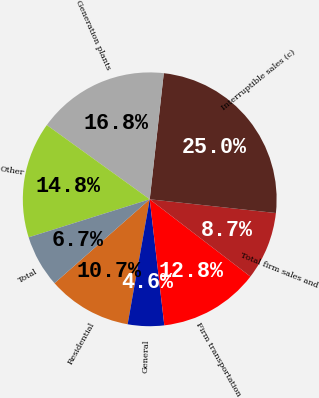Convert chart to OTSL. <chart><loc_0><loc_0><loc_500><loc_500><pie_chart><fcel>Residential<fcel>General<fcel>Firm transportation<fcel>Total firm sales and<fcel>Interruptible sales (c)<fcel>Generation plants<fcel>Other<fcel>Total<nl><fcel>10.72%<fcel>4.62%<fcel>12.75%<fcel>8.69%<fcel>24.96%<fcel>16.82%<fcel>14.79%<fcel>6.65%<nl></chart> 